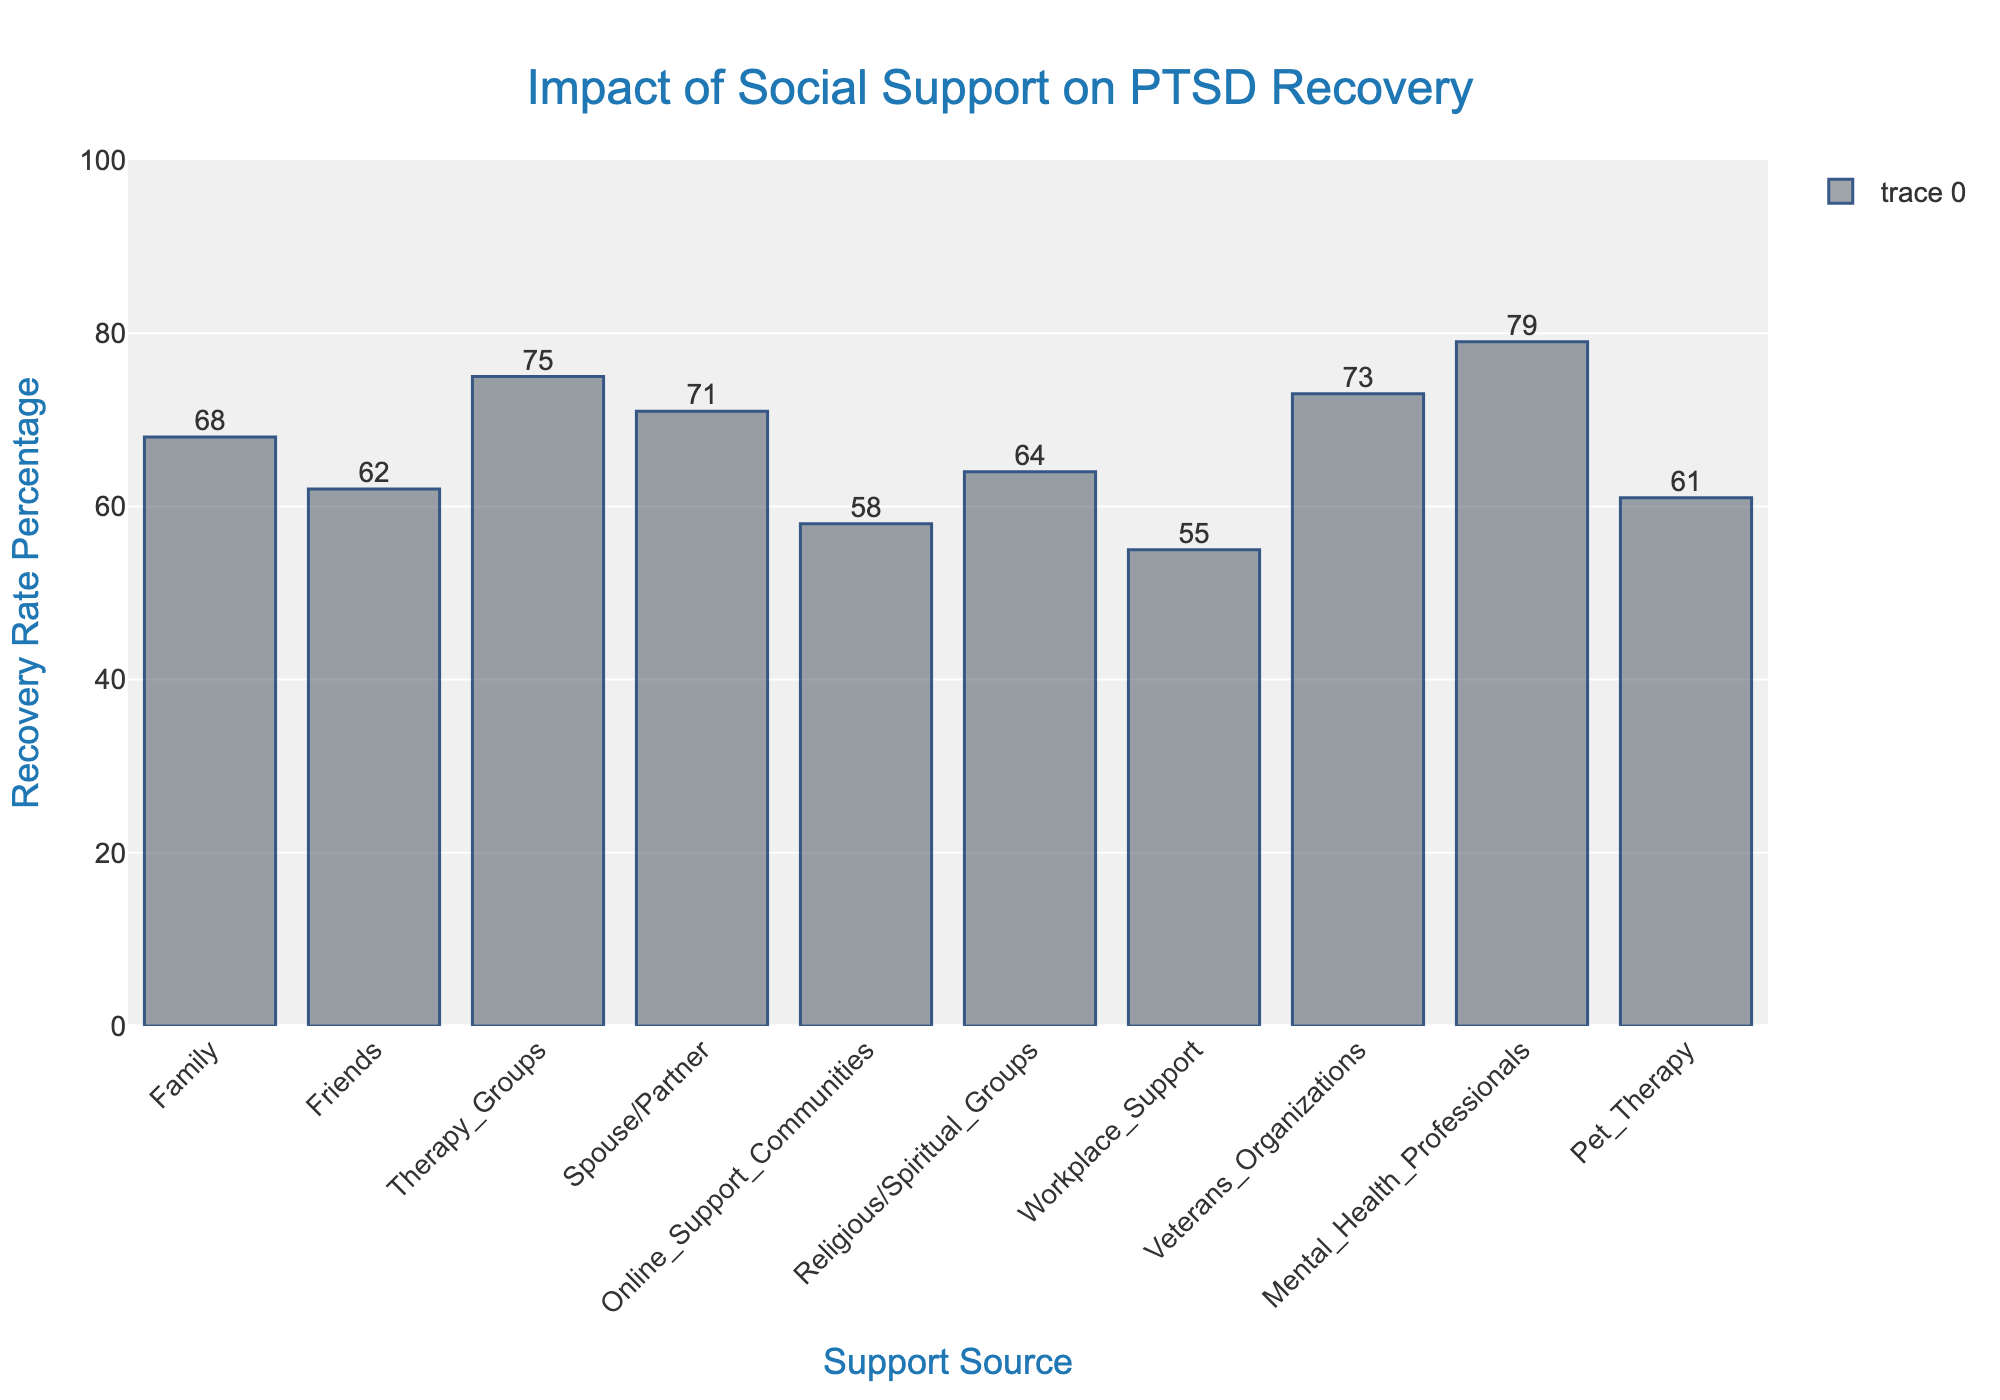What is the recovery rate for people supported by Veterans Organizations? Look for the bar representing Veterans Organizations and check its height, which corresponds to the recovery rate percentage.
Answer: 73% Which support source has the highest recovery rate? Identify the tallest bar in the bar chart, which corresponds to the support source with the highest recovery rate.
Answer: Mental Health Professionals How much higher is the recovery rate with Spouse/Partner support compared to Online Support Communities? Subtract the recovery rate of Online Support Communities from the recovery rate of Spouse/Partner.
Answer: 13% What is the average recovery rate among all the support sources? Add the recovery rates of all support sources and divide by the number of support sources: (68 + 62 + 75 + 71 + 58 + 64 + 55 + 73 + 79 + 61) / 10.
Answer: 66.6% Are there any support sources with a recovery rate below 60%? Identify the bars that fall below the 60% mark on the y-axis.
Answer: Yes, Online Support Communities and Workplace Support Which two support sources have the closest recovery rates? Compare the recovery rates to find the two sources with the smallest difference in their percentages.
Answer: Friends and Pet Therapy How does the recovery rate of Religious/Spiritual Groups compare to that of Therapy Groups? Compare the height of the bars for Religious/Spiritual Groups and Therapy Groups to determine if one is higher or lower than the other.
Answer: Therapy Groups have a higher recovery rate What is the difference between the highest and lowest recovery rates in the chart? Subtract the lowest recovery rate from the highest recovery rate: 79 - 55.
Answer: 24% What is the second highest recovery rate for PTSD recovery shown in the chart? Identify the second tallest bar after the one representing the highest value and check its height.
Answer: 75% Which support source shows a recovery rate closest to the overall average recovery rate? Calculate the overall average recovery rate, then find the support source whose rate is closest to this average. Average = 66.6%.
Answer: Friends 